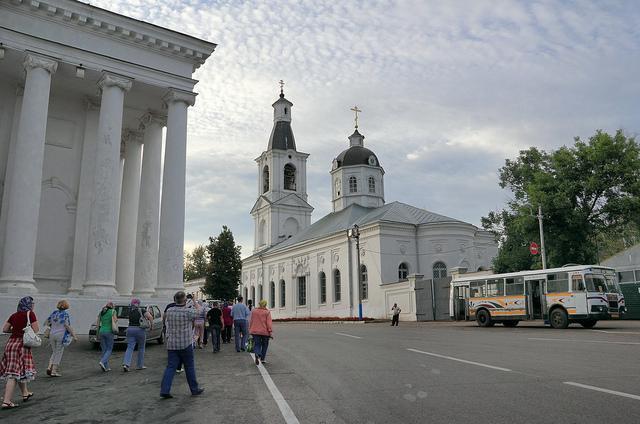How many people are in a red shirt?
Give a very brief answer. 2. How many people are there?
Give a very brief answer. 2. 